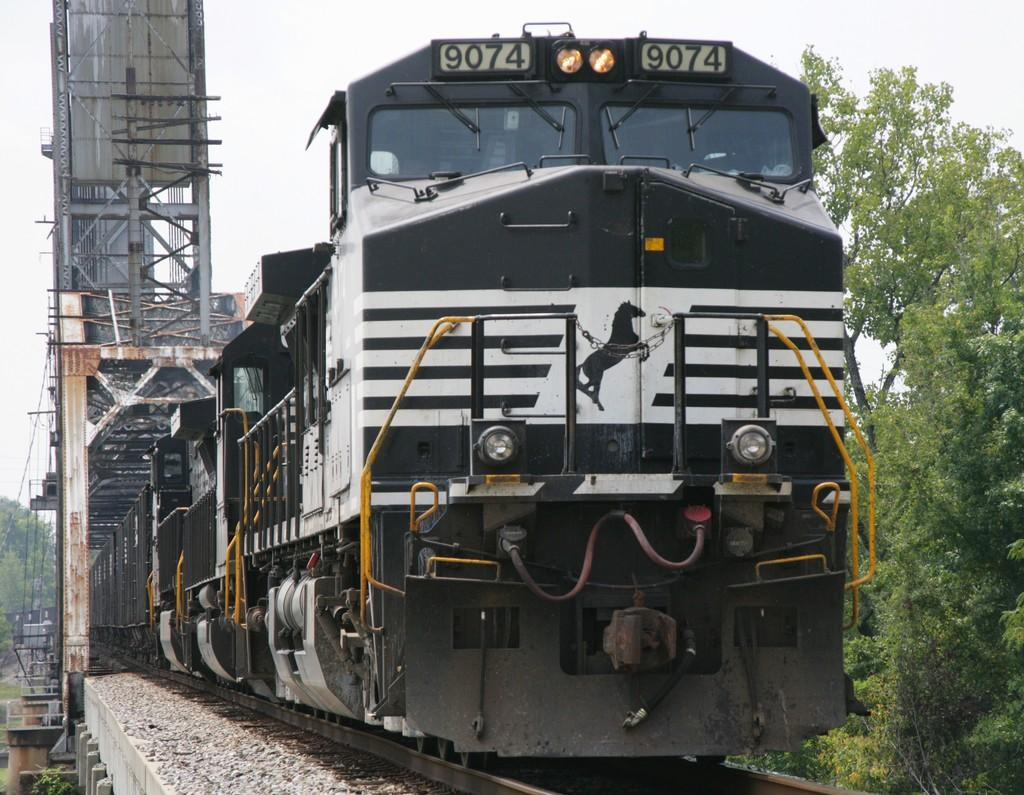What is the main subject of the image? There is a train in the image. Can you describe the train's position in the image? The train is on a track. What can be seen in the background of the image? There are poles and green trees in the background of the image. How would you describe the color of the sky in the image? The sky is white in color. How many copies of the foot can be seen in the image? There are no feet or copies of feet present in the image. 